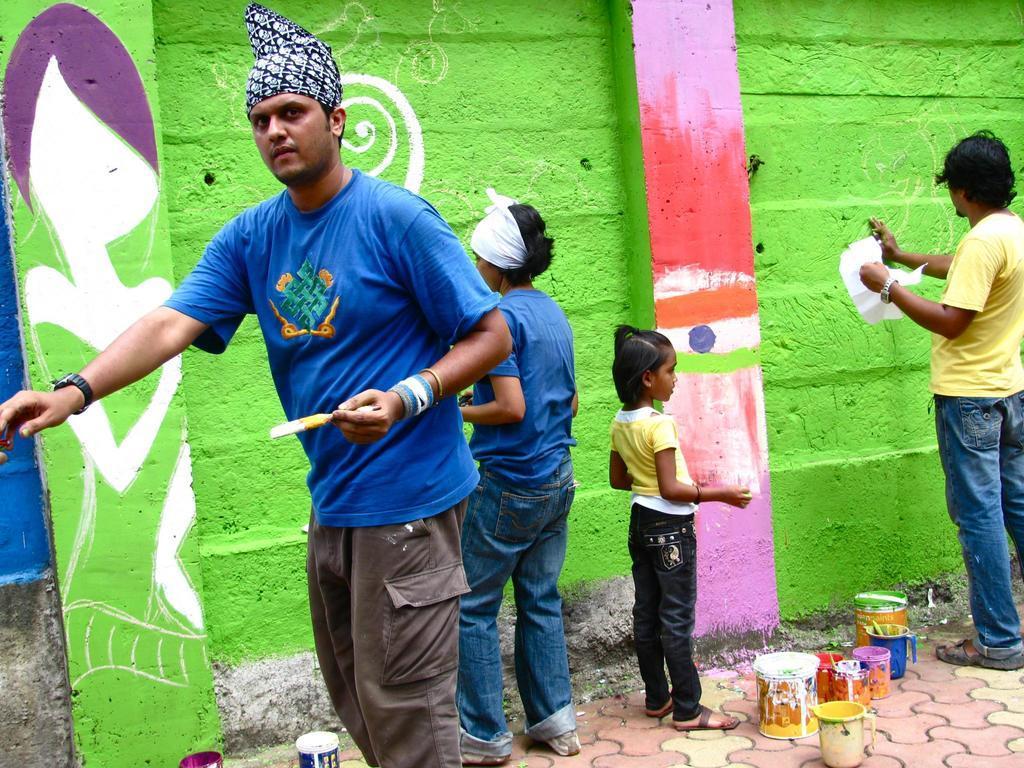Could you give a brief overview of what you see in this image? In the image we can see there are people standing and wearing clothes. Here we can see a wall and painting on the wall. The left person is wearing a wrist watch and holding a painting brush in hand. Here we can see footpath and on the footpath there are buckets and mugs. 